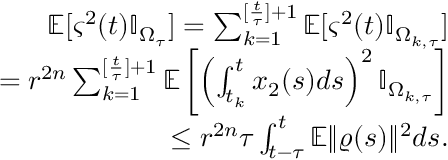<formula> <loc_0><loc_0><loc_500><loc_500>\begin{array} { r l r } & { \mathbb { E } [ \varsigma ^ { 2 } ( t ) \mathbb { I } _ { \Omega _ { \tau } } ] = \sum _ { k = 1 } ^ { [ \frac { t } { \tau } ] + 1 } \mathbb { E } [ \varsigma ^ { 2 } ( t ) \mathbb { I } _ { \Omega _ { k , \tau } } ] } \\ & { = r ^ { 2 n } \sum _ { k = 1 } ^ { [ \frac { t } { \tau } ] + 1 } \mathbb { E } \left [ \left ( \int _ { t _ { k } } ^ { t } x _ { 2 } ( s ) d s \right ) ^ { 2 } \mathbb { I } _ { \Omega _ { k , \tau } } \right ] } \\ & { \leq r ^ { 2 n } \tau \int _ { t - \tau } ^ { t } \mathbb { E } \| \varrho ( s ) \| ^ { 2 } d s . } \end{array}</formula> 